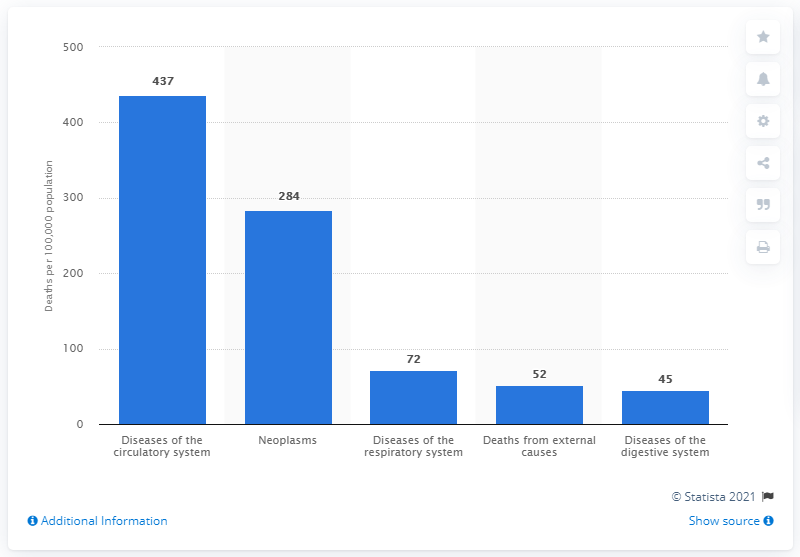Point out several critical features in this image. In 2018, the death rate in Poland due to circulatory system diseases was 437 per 100,000 persons. 